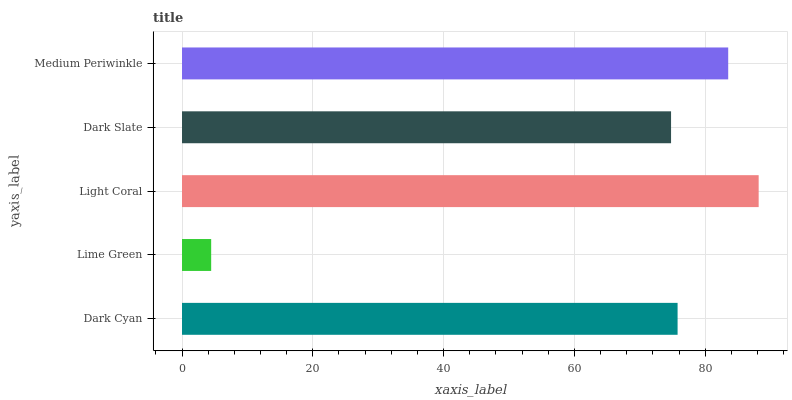Is Lime Green the minimum?
Answer yes or no. Yes. Is Light Coral the maximum?
Answer yes or no. Yes. Is Light Coral the minimum?
Answer yes or no. No. Is Lime Green the maximum?
Answer yes or no. No. Is Light Coral greater than Lime Green?
Answer yes or no. Yes. Is Lime Green less than Light Coral?
Answer yes or no. Yes. Is Lime Green greater than Light Coral?
Answer yes or no. No. Is Light Coral less than Lime Green?
Answer yes or no. No. Is Dark Cyan the high median?
Answer yes or no. Yes. Is Dark Cyan the low median?
Answer yes or no. Yes. Is Light Coral the high median?
Answer yes or no. No. Is Dark Slate the low median?
Answer yes or no. No. 